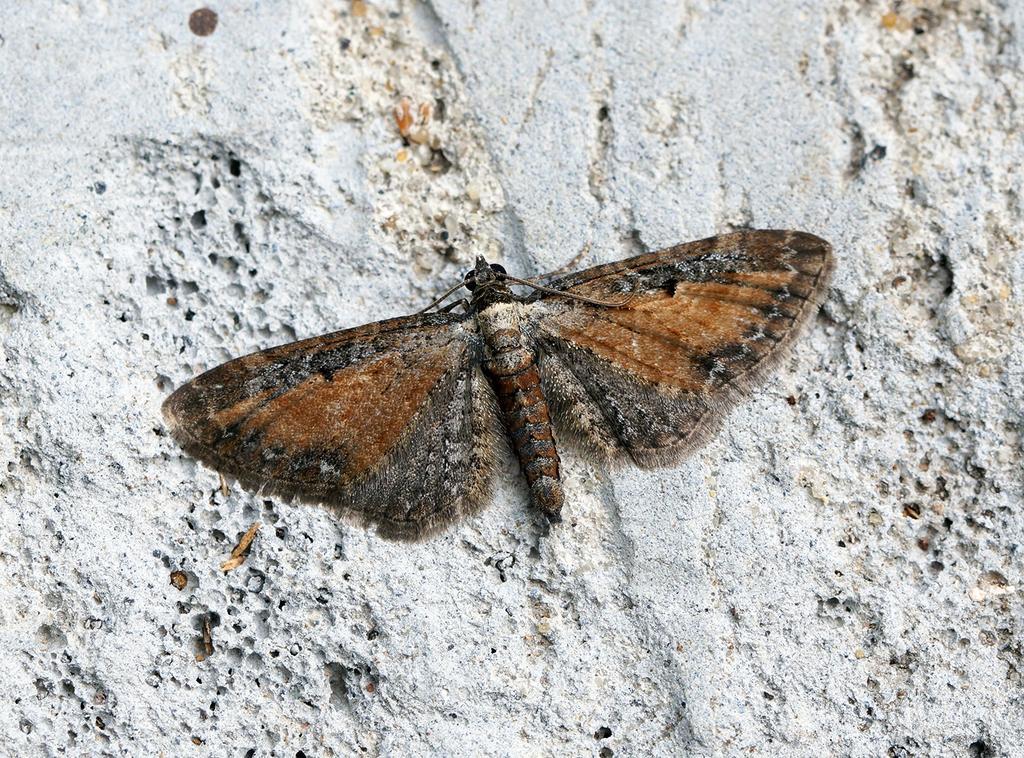How would you summarize this image in a sentence or two? There is a brown color butterfly on a white wall. 